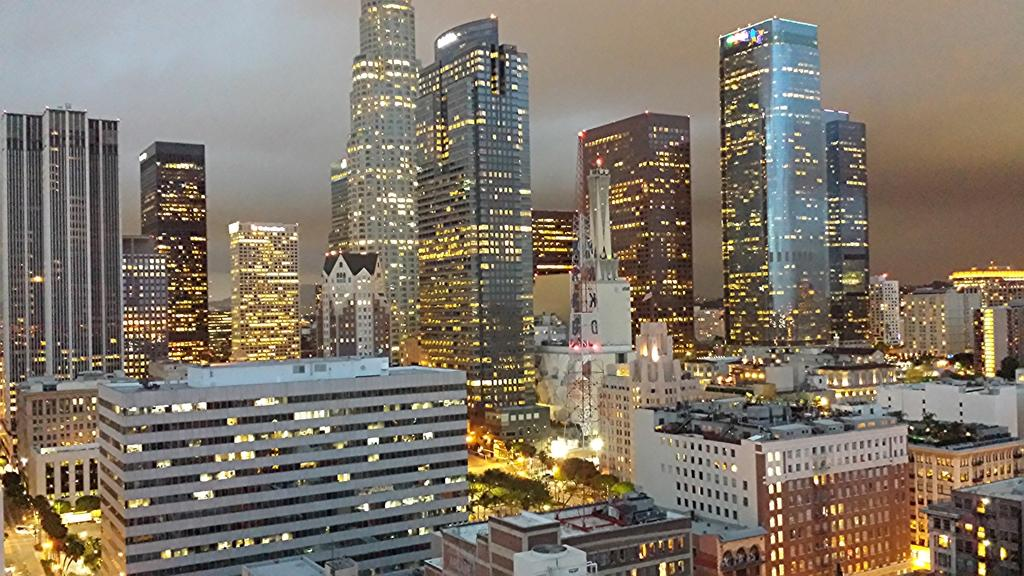What type of structures can be seen in the image? There are buildings and a tower in the image. What else is present in the image besides the structures? There is a road and trees in the image. What can be seen in the background of the image? The sky is visible in the background of the image. What type of celery can be seen growing on the side of the tower in the image? There is no celery present in the image, and the tower does not have any plants growing on it. 